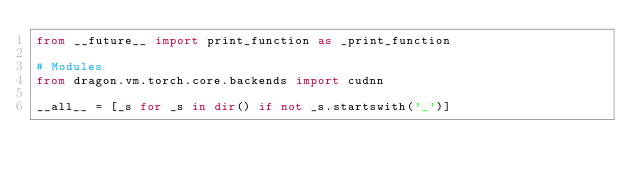Convert code to text. <code><loc_0><loc_0><loc_500><loc_500><_Python_>from __future__ import print_function as _print_function

# Modules
from dragon.vm.torch.core.backends import cudnn

__all__ = [_s for _s in dir() if not _s.startswith('_')]
</code> 